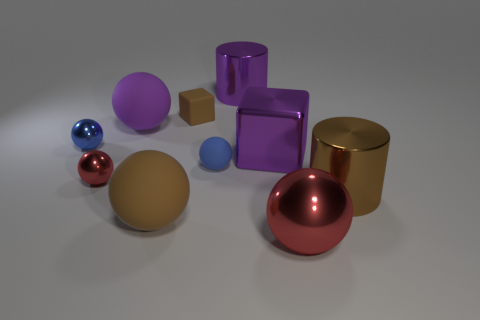There is a thing that is the same color as the tiny rubber ball; what shape is it?
Offer a very short reply. Sphere. How many other things are made of the same material as the large purple cube?
Give a very brief answer. 5. There is a brown thing that is both in front of the blue metal sphere and on the left side of the big red shiny ball; what is its shape?
Give a very brief answer. Sphere. There is a big block; is it the same color as the big rubber thing behind the metallic block?
Provide a short and direct response. Yes. Does the metallic cylinder that is behind the brown block have the same size as the matte cube?
Offer a terse response. No. What material is the other red thing that is the same shape as the big red thing?
Make the answer very short. Metal. Is the small blue rubber object the same shape as the brown metal thing?
Offer a very short reply. No. How many red metallic balls are on the right side of the large brown object to the right of the big red metallic sphere?
Provide a short and direct response. 0. There is a purple thing that is made of the same material as the big cube; what is its shape?
Offer a very short reply. Cylinder. What number of blue things are either large metallic cylinders or tiny objects?
Keep it short and to the point. 2. 